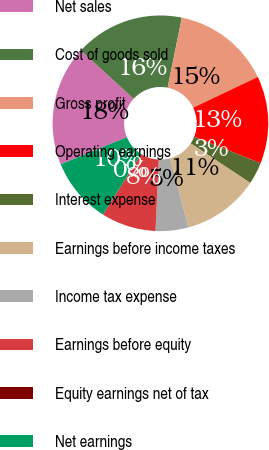<chart> <loc_0><loc_0><loc_500><loc_500><pie_chart><fcel>Net sales<fcel>Cost of goods sold<fcel>Gross profit<fcel>Operating earnings<fcel>Interest expense<fcel>Earnings before income taxes<fcel>Income tax expense<fcel>Earnings before equity<fcel>Equity earnings net of tax<fcel>Net earnings<nl><fcel>18.02%<fcel>16.38%<fcel>14.75%<fcel>13.11%<fcel>3.29%<fcel>11.47%<fcel>4.93%<fcel>8.2%<fcel>0.02%<fcel>9.84%<nl></chart> 